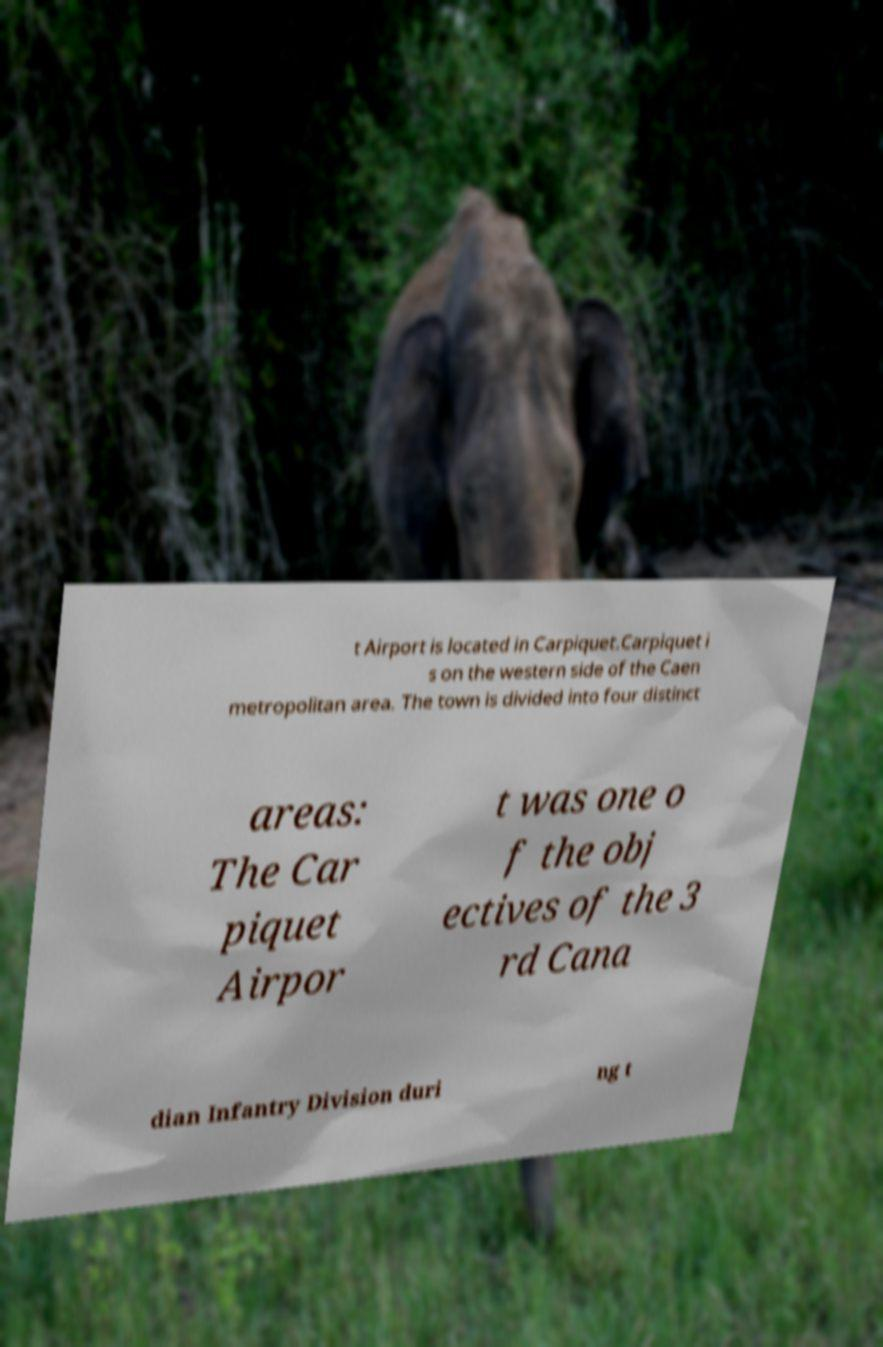Could you assist in decoding the text presented in this image and type it out clearly? t Airport is located in Carpiquet.Carpiquet i s on the western side of the Caen metropolitan area. The town is divided into four distinct areas: The Car piquet Airpor t was one o f the obj ectives of the 3 rd Cana dian Infantry Division duri ng t 